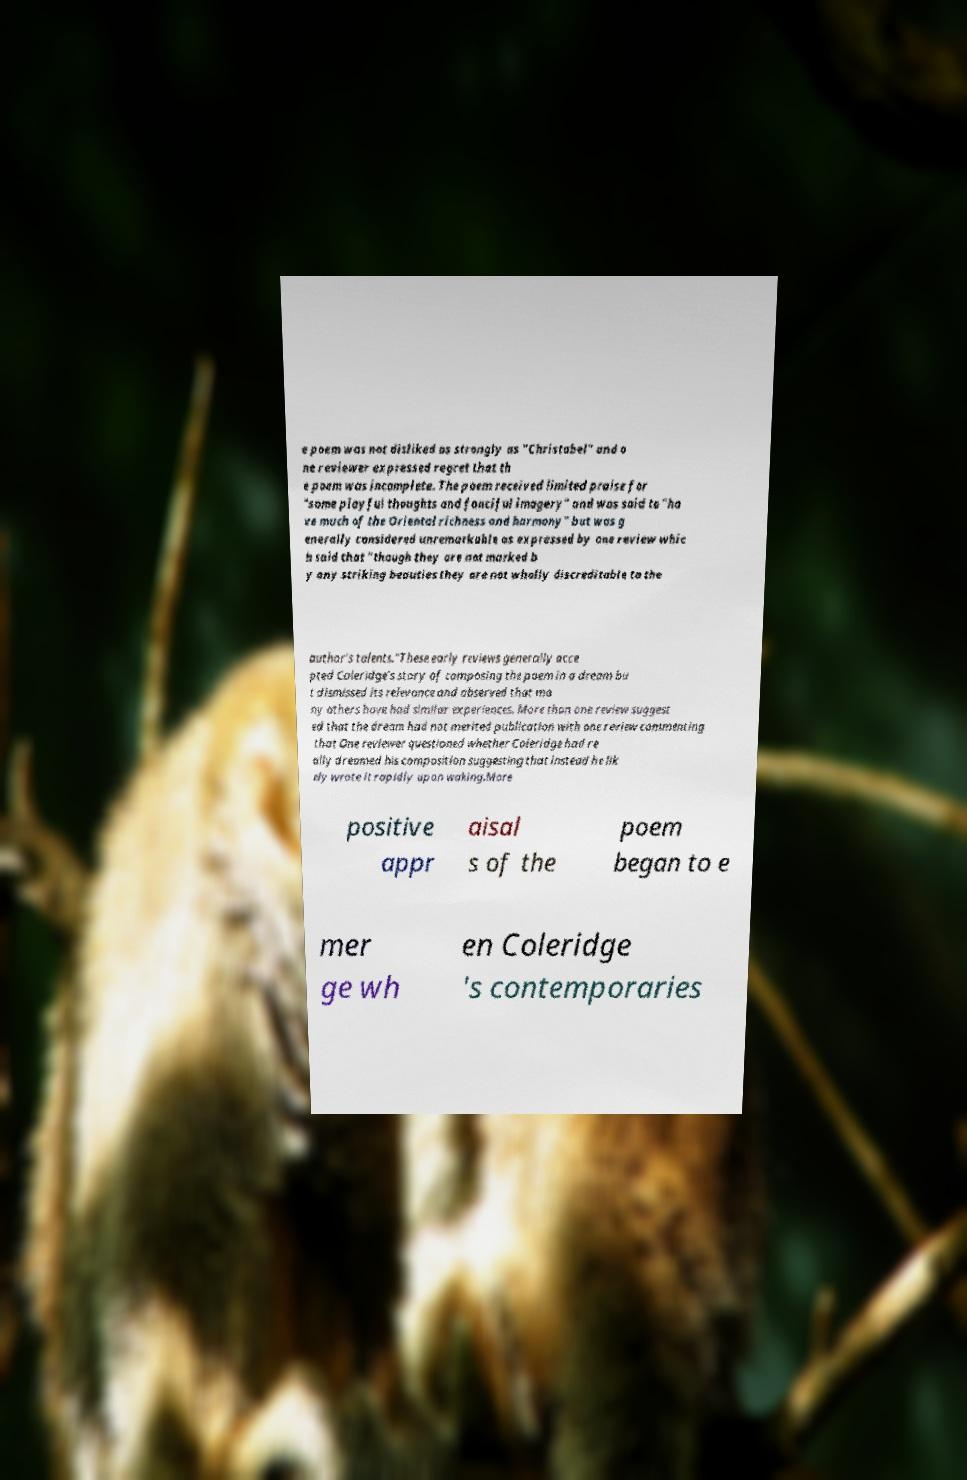Please identify and transcribe the text found in this image. e poem was not disliked as strongly as "Christabel" and o ne reviewer expressed regret that th e poem was incomplete. The poem received limited praise for "some playful thoughts and fanciful imagery" and was said to "ha ve much of the Oriental richness and harmony" but was g enerally considered unremarkable as expressed by one review whic h said that "though they are not marked b y any striking beauties they are not wholly discreditable to the author's talents."These early reviews generally acce pted Coleridge's story of composing the poem in a dream bu t dismissed its relevance and observed that ma ny others have had similar experiences. More than one review suggest ed that the dream had not merited publication with one review commenting that One reviewer questioned whether Coleridge had re ally dreamed his composition suggesting that instead he lik ely wrote it rapidly upon waking.More positive appr aisal s of the poem began to e mer ge wh en Coleridge 's contemporaries 